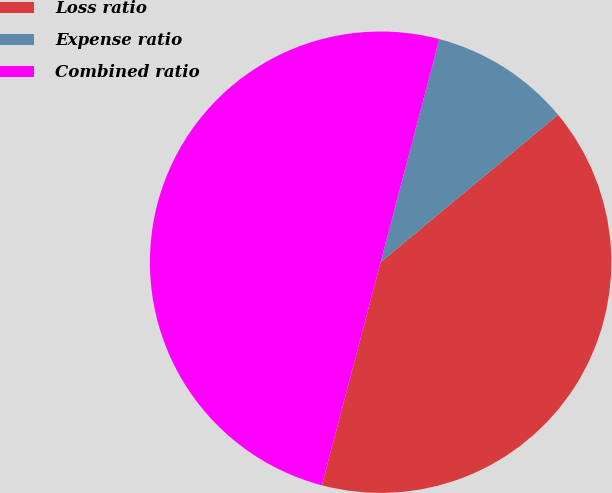Convert chart. <chart><loc_0><loc_0><loc_500><loc_500><pie_chart><fcel>Loss ratio<fcel>Expense ratio<fcel>Combined ratio<nl><fcel>40.13%<fcel>9.87%<fcel>50.0%<nl></chart> 